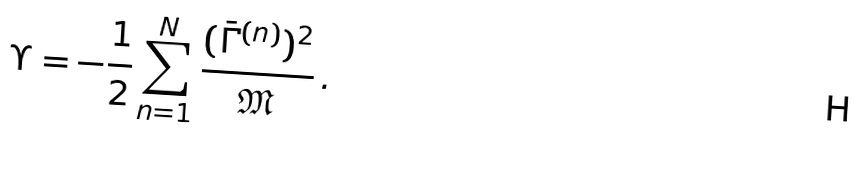Convert formula to latex. <formula><loc_0><loc_0><loc_500><loc_500>\Upsilon = - { \frac { 1 } { 2 } } \sum _ { n = 1 } ^ { N } \frac { ( \bar { \Gamma } ^ { ( n ) } ) ^ { 2 } } { \mathfrak { M } } \, .</formula> 